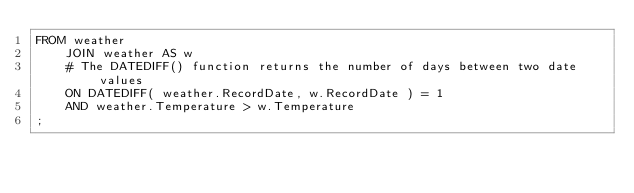<code> <loc_0><loc_0><loc_500><loc_500><_SQL_>FROM weather
    JOIN weather AS w
    # The DATEDIFF() function returns the number of days between two date values
    ON DATEDIFF( weather.RecordDate, w.RecordDate ) = 1
    AND weather.Temperature > w.Temperature
;

</code> 